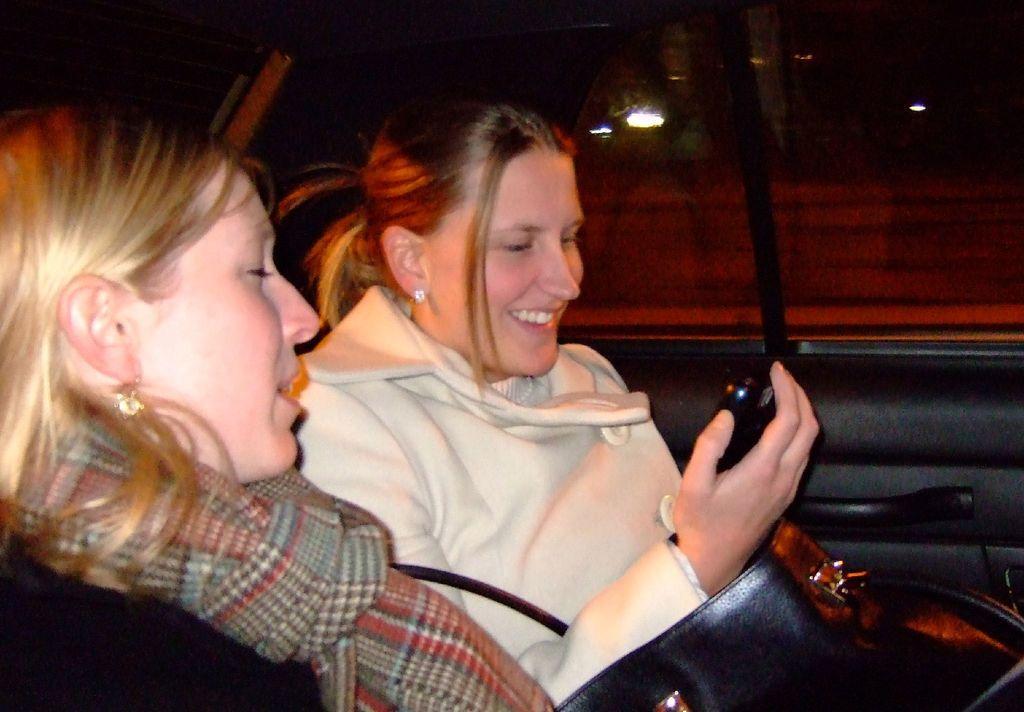Can you describe this image briefly? In this picture we can see two women inside of a vehicle and one woman is holding a mobile, here we can see a bag and in the background we can see lights, some objects. 